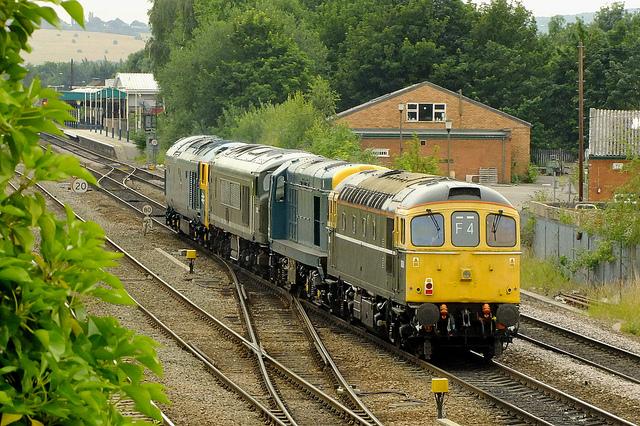Are the buildings abandoned?
Keep it brief. No. Are there multiple train tracks?
Write a very short answer. Yes. Where is the train station?
Answer briefly. Behind train. 